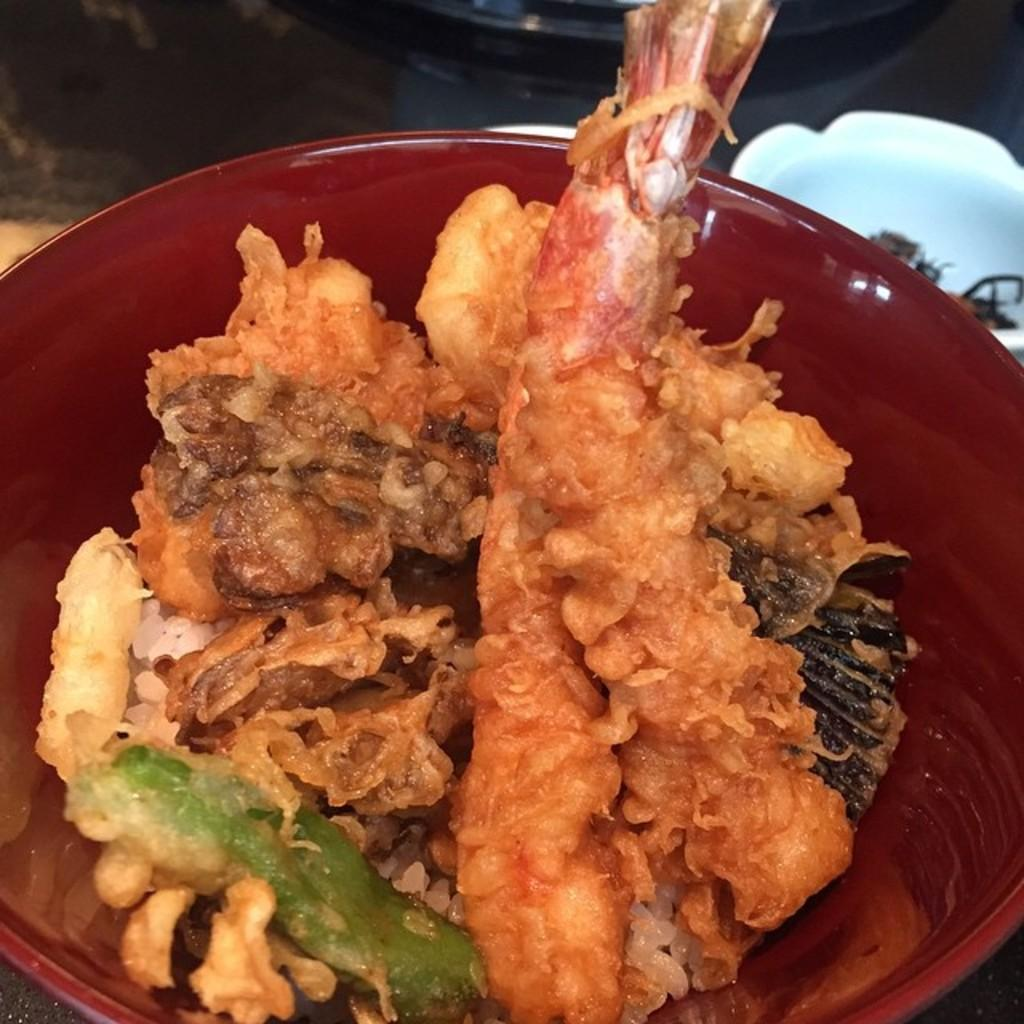What is in the bowl that is visible in the image? There are food items in a bowl in the image. What type of bell can be heard ringing in the image? There is no bell present in the image, and therefore no sound can be heard. 